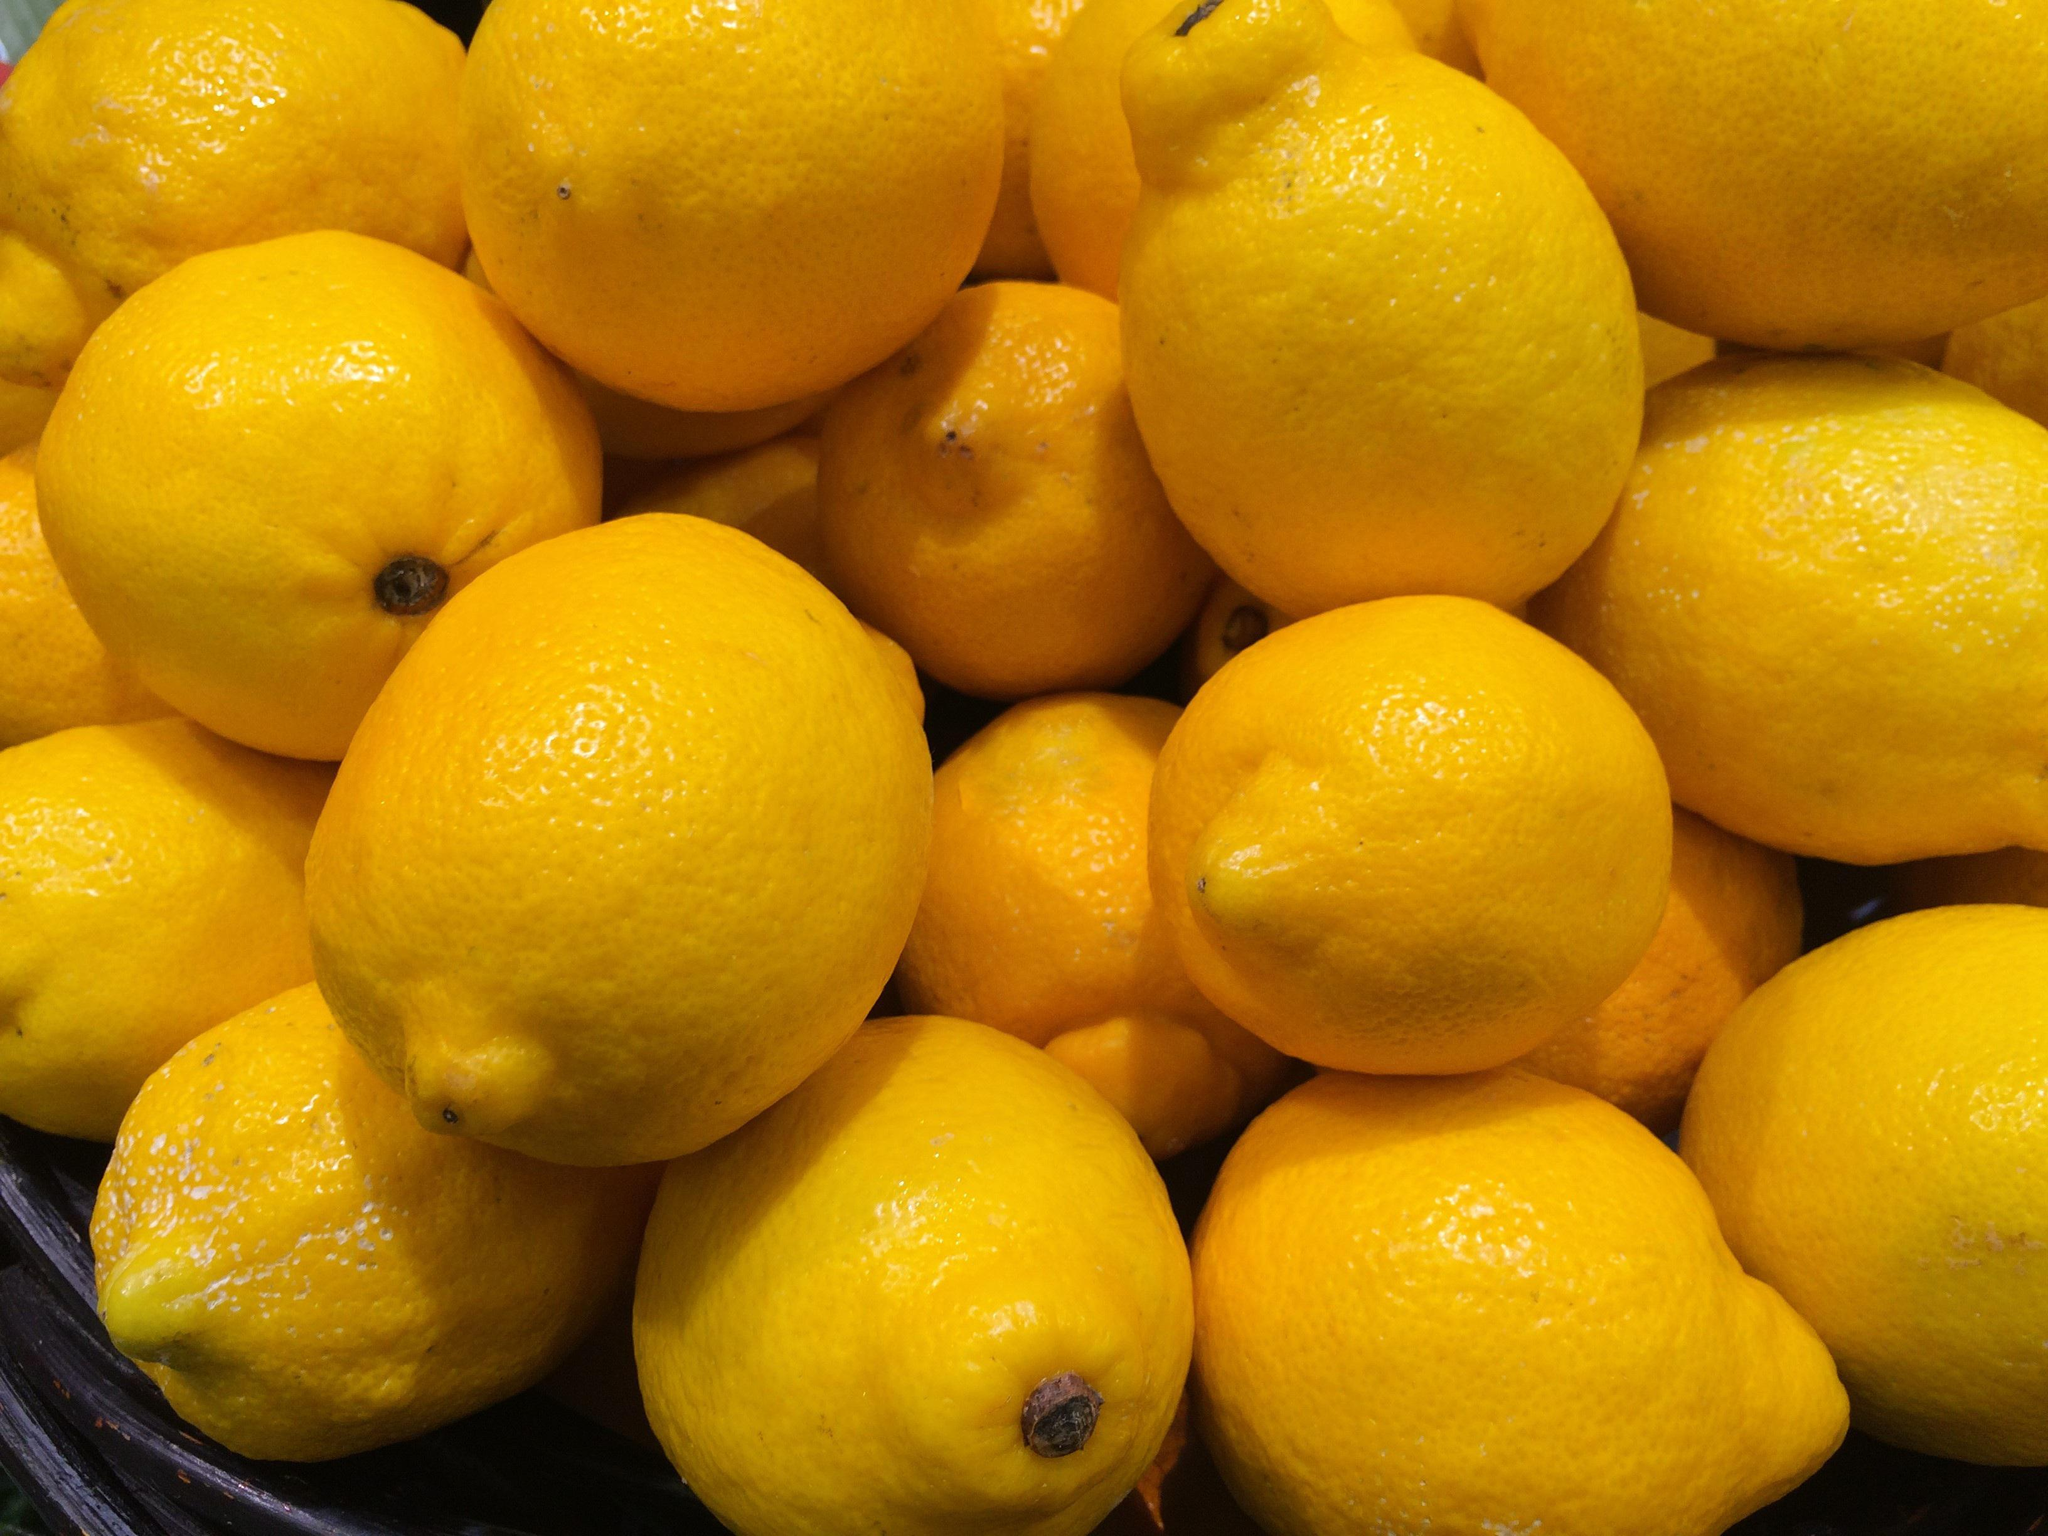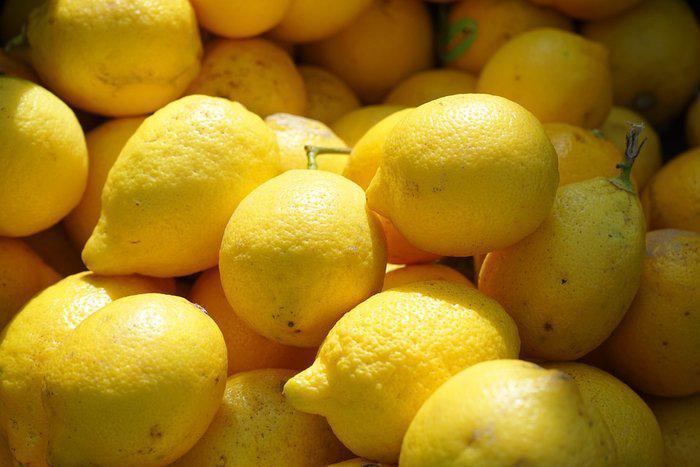The first image is the image on the left, the second image is the image on the right. For the images shown, is this caption "There are lemons inside a box." true? Answer yes or no. No. The first image is the image on the left, the second image is the image on the right. Given the left and right images, does the statement "In at least one image there is a a cardboard box holding at least 6 rows of wrapped and unwrapped lemon." hold true? Answer yes or no. No. 